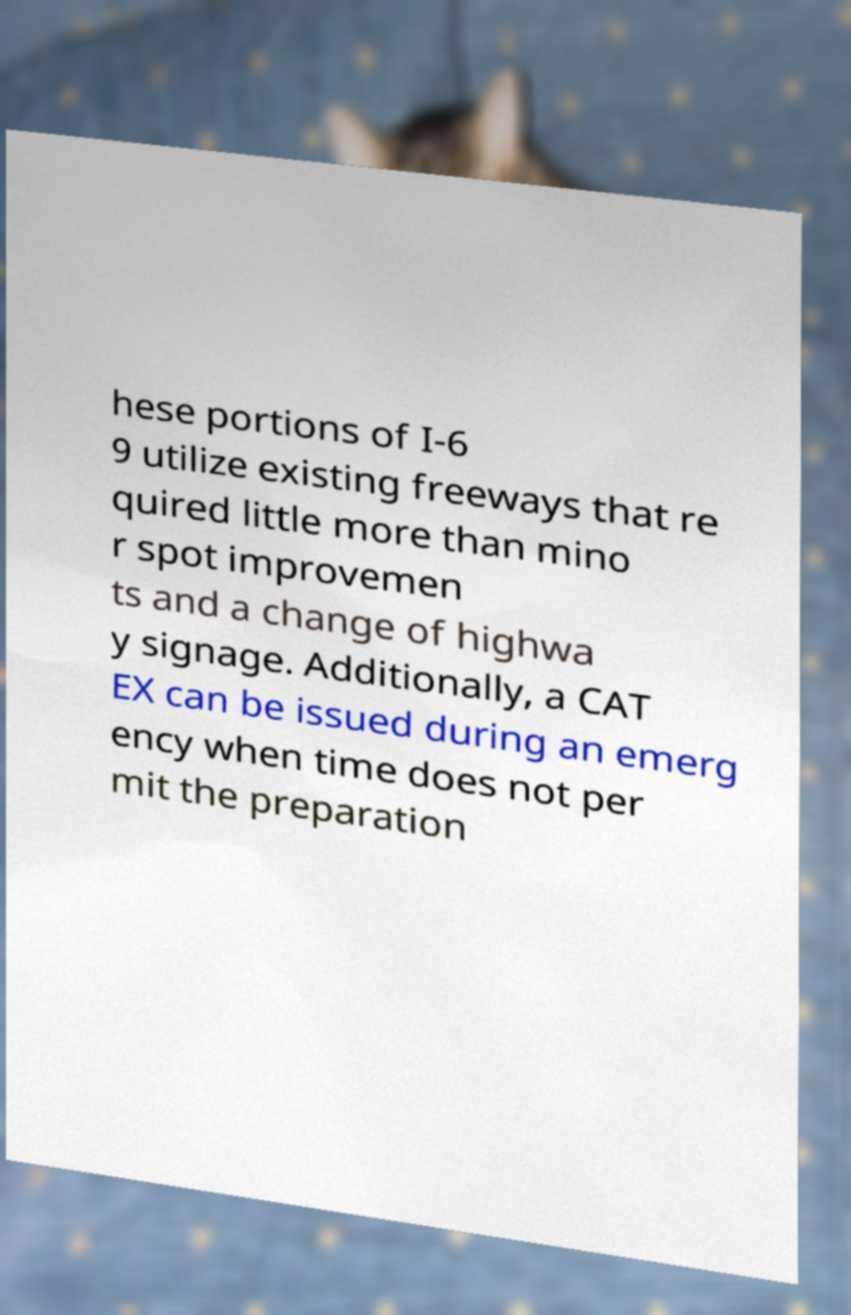For documentation purposes, I need the text within this image transcribed. Could you provide that? hese portions of I-6 9 utilize existing freeways that re quired little more than mino r spot improvemen ts and a change of highwa y signage. Additionally, a CAT EX can be issued during an emerg ency when time does not per mit the preparation 